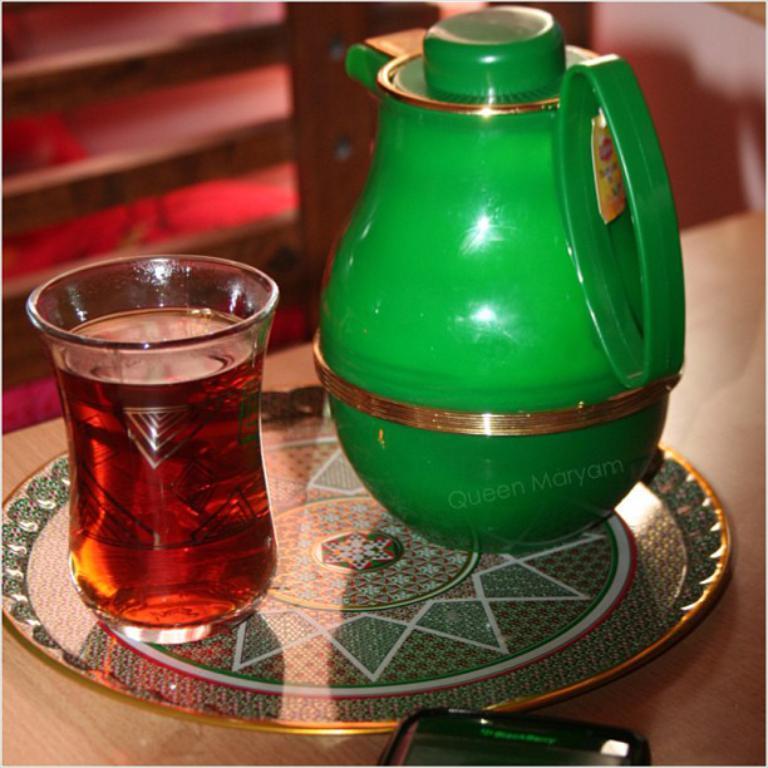Please provide a concise description of this image. In this image we can see a green color kettle and glass is kept in a plate. Bottom of the image mobile is there. 